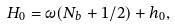<formula> <loc_0><loc_0><loc_500><loc_500>H _ { 0 } = \omega ( N _ { b } + 1 / 2 ) + h _ { 0 } ,</formula> 